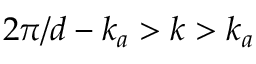Convert formula to latex. <formula><loc_0><loc_0><loc_500><loc_500>2 \pi / d - k _ { a } > k > k _ { a }</formula> 